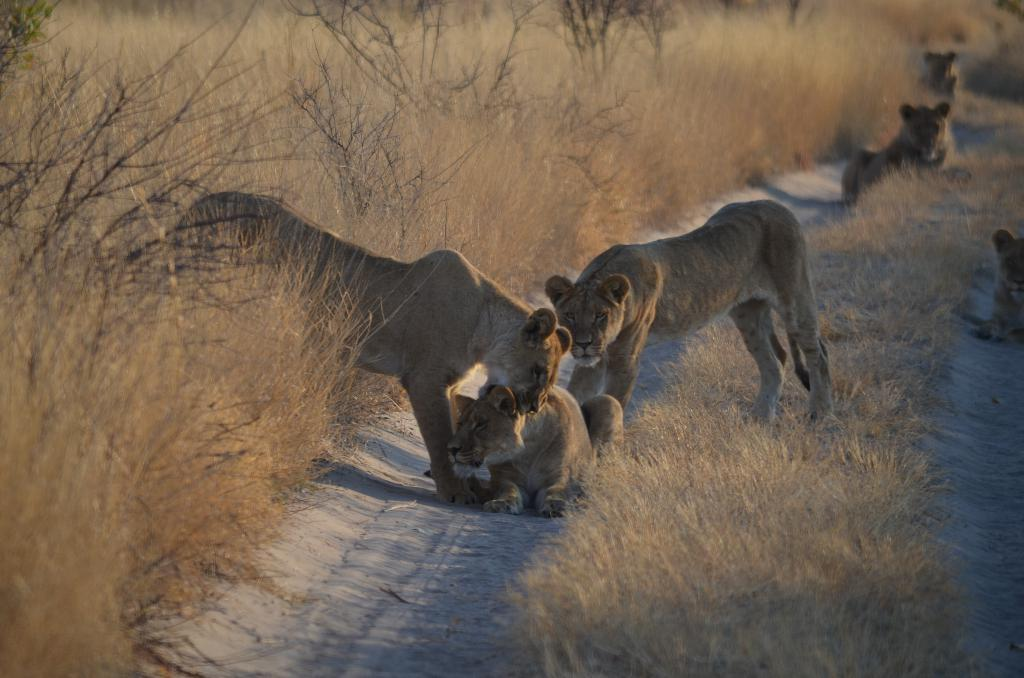What type of animals are in the image? There are tigers in the image. What are the tigers doing in the image? The tigers are sitting and standing on the ground in the image. What type of vegetation can be seen in the image? There is grass visible in the image, as well as plants. What type of pen is visible in the image? There is no pen present in the image; it features tigers, grass, and plants. 